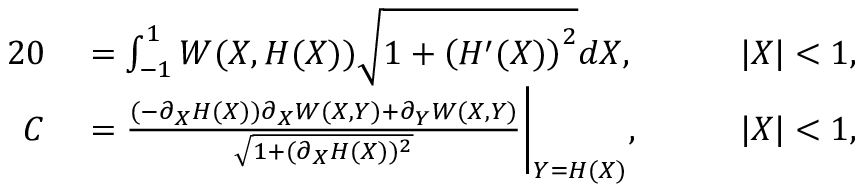<formula> <loc_0><loc_0><loc_500><loc_500>\begin{array} { r l r l } { { 2 } 0 } & = \int _ { - 1 } ^ { 1 } W ( X , H ( X ) ) \sqrt { 1 + \left ( H ^ { \prime } ( X ) \right ) ^ { 2 } } d X , } & \quad | X | < 1 , } \\ { C } & = \frac { ( - \partial _ { X } H ( X ) ) \partial _ { X } W ( X , Y ) + \partial _ { Y } W ( X , Y ) } { \sqrt { 1 + ( \partial _ { X } H ( X ) ) ^ { 2 } } } \Big | _ { Y = H ( X ) } , } & \quad | X | < 1 , } \end{array}</formula> 